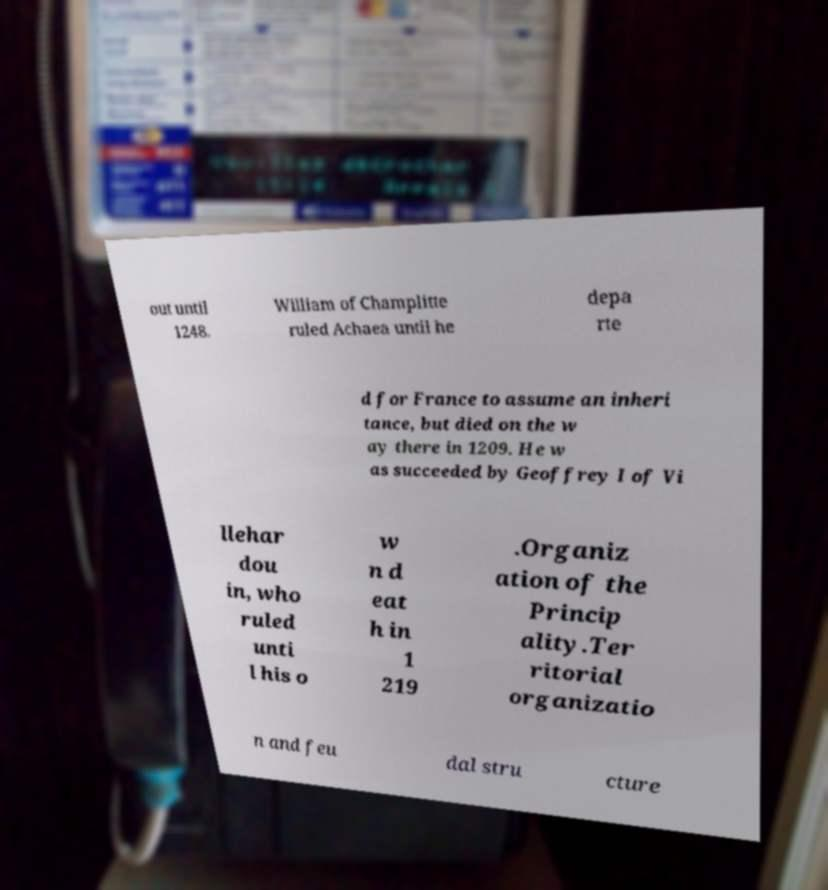Could you assist in decoding the text presented in this image and type it out clearly? out until 1248. William of Champlitte ruled Achaea until he depa rte d for France to assume an inheri tance, but died on the w ay there in 1209. He w as succeeded by Geoffrey I of Vi llehar dou in, who ruled unti l his o w n d eat h in 1 219 .Organiz ation of the Princip ality.Ter ritorial organizatio n and feu dal stru cture 